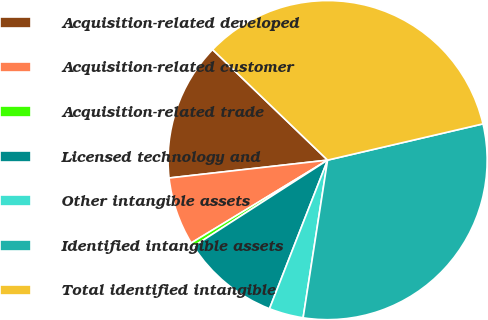Convert chart to OTSL. <chart><loc_0><loc_0><loc_500><loc_500><pie_chart><fcel>Acquisition-related developed<fcel>Acquisition-related customer<fcel>Acquisition-related trade<fcel>Licensed technology and<fcel>Other intangible assets<fcel>Identified intangible assets<fcel>Total identified intangible<nl><fcel>13.97%<fcel>6.9%<fcel>0.41%<fcel>9.97%<fcel>3.48%<fcel>31.1%<fcel>34.17%<nl></chart> 